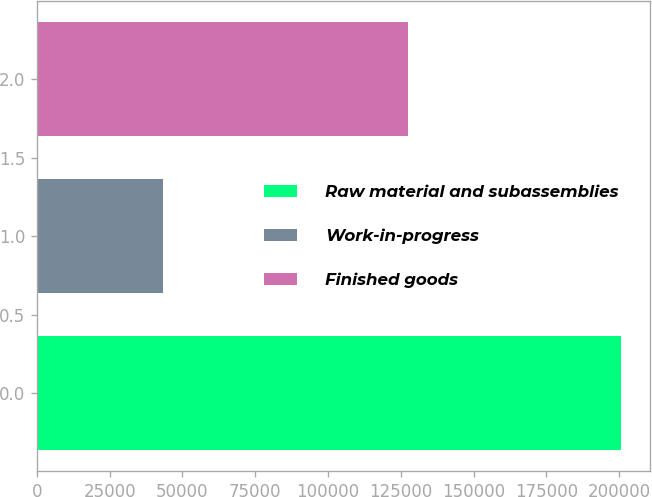<chart> <loc_0><loc_0><loc_500><loc_500><bar_chart><fcel>Raw material and subassemblies<fcel>Work-in-progress<fcel>Finished goods<nl><fcel>200640<fcel>43430<fcel>127301<nl></chart> 